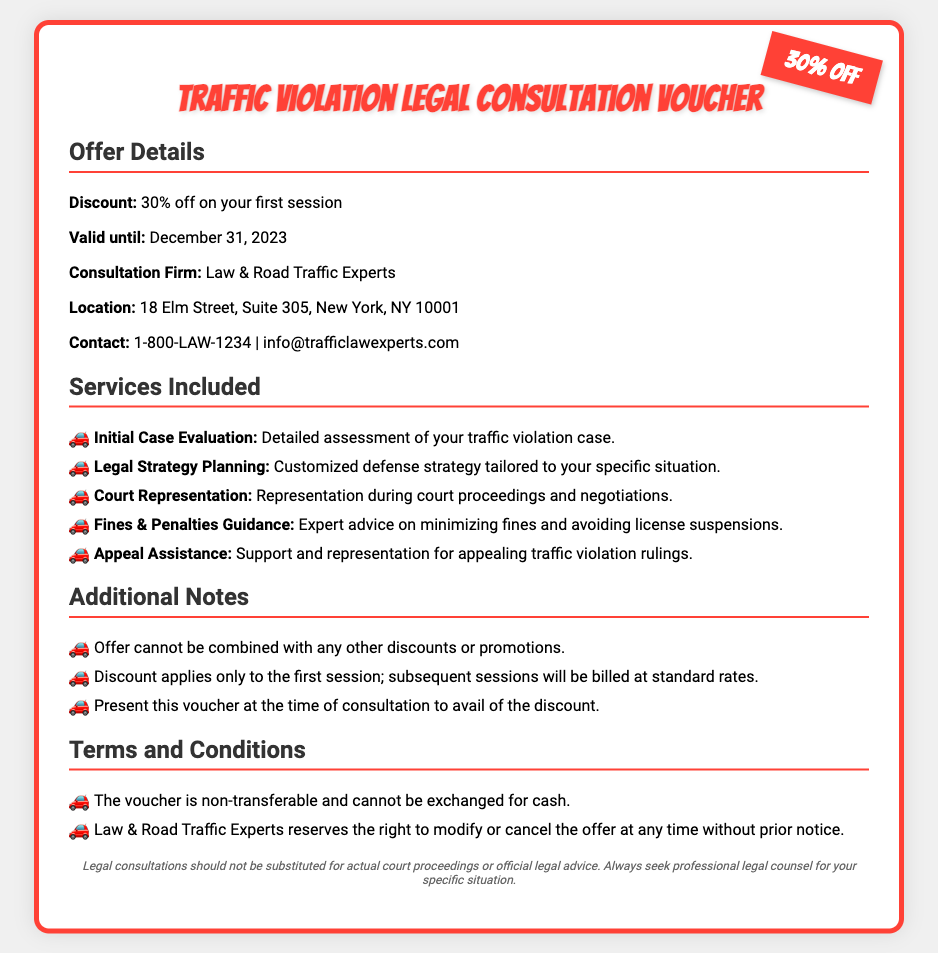What is the discount percentage? The discount percentage offered on the first session is clearly stated in the document.
Answer: 30% off Who is the consultation firm? The document specifies the name of the legal consultation firm providing the service.
Answer: Law & Road Traffic Experts What is the location of the consultation firm? The document includes the address where the consultation firm is located.
Answer: 18 Elm Street, Suite 305, New York, NY 10001 What is the last valid date for using the voucher? The document provides the expiration date for the discount offered by the voucher.
Answer: December 31, 2023 What services are included in the consultation? The document lists various services included in the consultation offered.
Answer: Initial Case Evaluation, Legal Strategy Planning, Court Representation, Fines & Penalties Guidance, Appeal Assistance Can this offer be combined with other discounts? The document contains a note regarding combining this offer with other promotions.
Answer: No Is the voucher transferable? The document outlines a specific term related to the voucher's transferability.
Answer: No What type of assistance does the voucher provide for traffic violations? The document defines the nature of the legal assistance provided under the voucher.
Answer: Legal consultation What must be done to avail of the discount? The document specifies a requirement necessary to utilize the voucher discount at the consultation.
Answer: Present this voucher at the time of consultation 